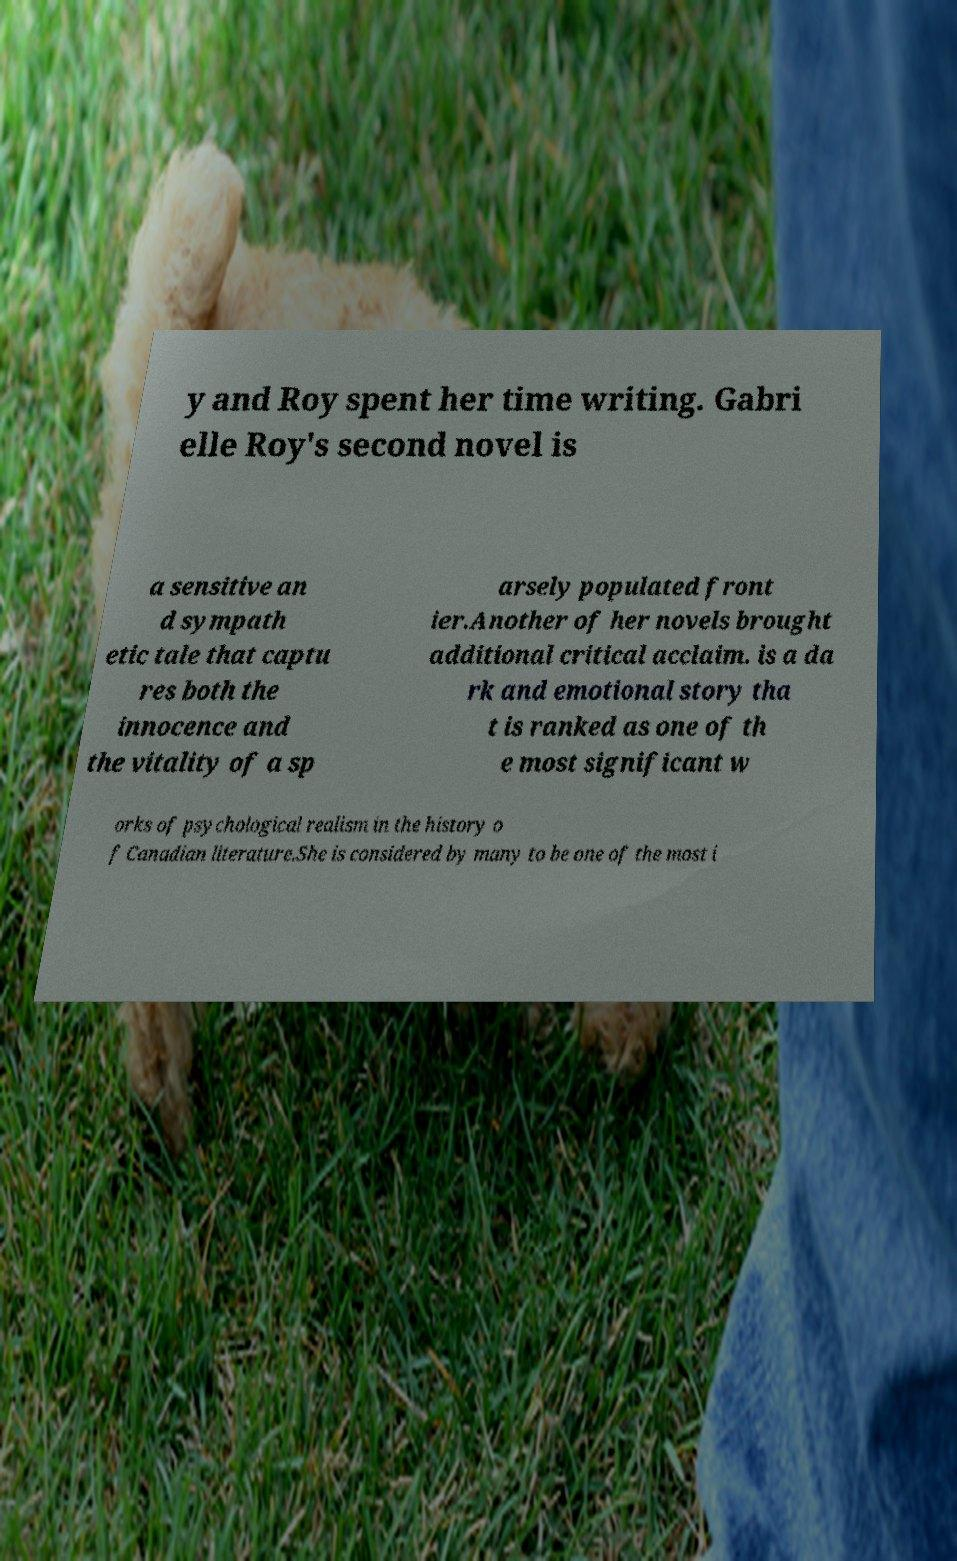There's text embedded in this image that I need extracted. Can you transcribe it verbatim? y and Roy spent her time writing. Gabri elle Roy's second novel is a sensitive an d sympath etic tale that captu res both the innocence and the vitality of a sp arsely populated front ier.Another of her novels brought additional critical acclaim. is a da rk and emotional story tha t is ranked as one of th e most significant w orks of psychological realism in the history o f Canadian literature.She is considered by many to be one of the most i 